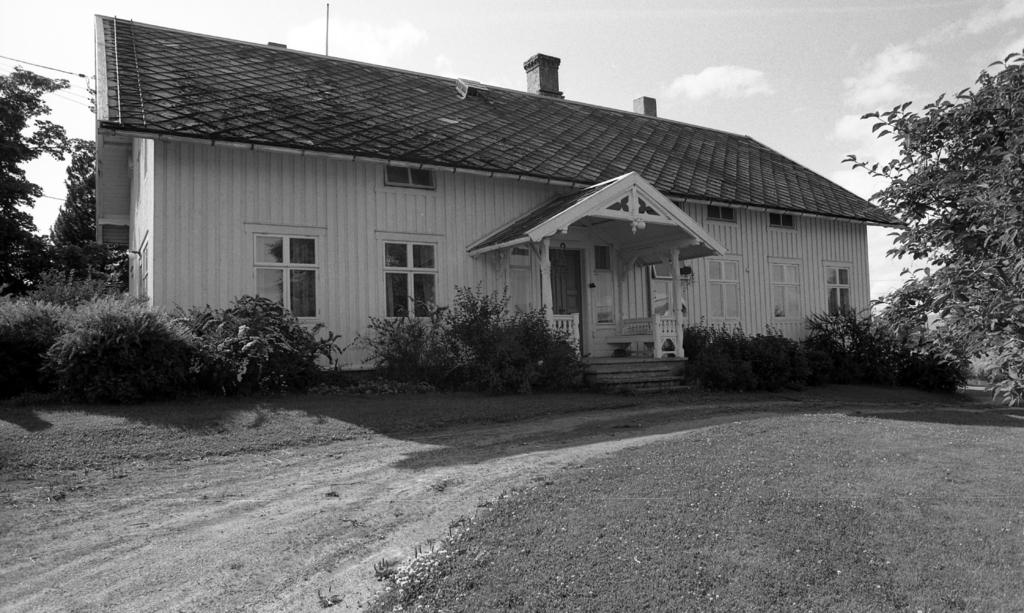What type of structure is in the image? There is a house in the image. What is located in front of the house? Plants and a road are visible in front of the house. What type of vegetation can be seen in the image? Trees are visible in the image. What is visible at the top of the image? The sky is visible at the top of the image. How many cars are parked in the field next to the house? There is no field or cars present in the image; it only features a house, plants, a road, trees, and the sky. 